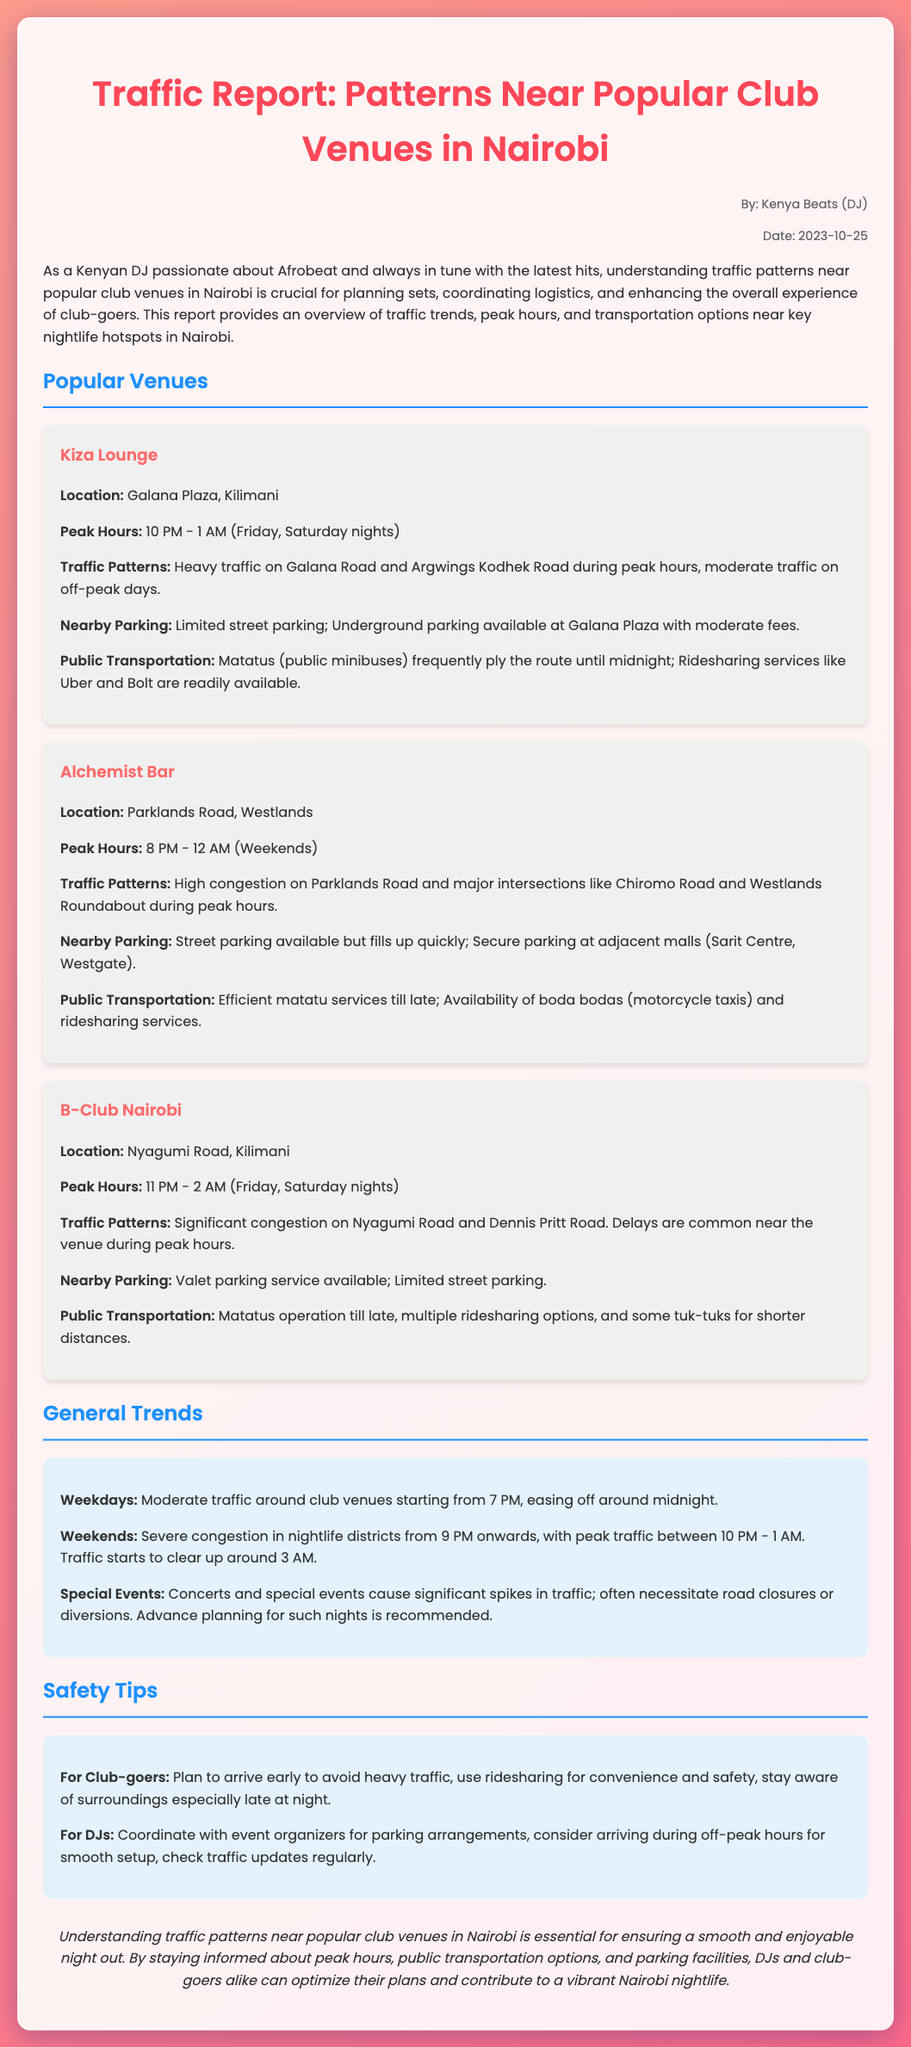What are the peak hours for Kiza Lounge? The peak hours for Kiza Lounge are specifically mentioned as 10 PM - 1 AM on Friday and Saturday nights.
Answer: 10 PM - 1 AM (Friday, Saturday nights) Where is Alchemist Bar located? The document specifies the location of Alchemist Bar as Parklands Road, Westlands.
Answer: Parklands Road, Westlands What type of traffic is experienced at B-Club Nairobi during peak hours? The document describes the traffic at B-Club Nairobi as significant congestion on Nyagumi Road and Dennis Pritt Road during peak hours.
Answer: Significant congestion What are the public transportation options for Kiza Lounge? The report mentions that matatus frequently ply the route until midnight and that ridesharing services like Uber and Bolt are readily available.
Answer: Matatus, Uber, Bolt What is suggested for DJs regarding parking arrangements? The report advises DJs to coordinate with event organizers for parking arrangements to ease logistics.
Answer: Coordinate with event organizers What impact do special events have on traffic? According to the report, special events cause significant spikes in traffic and often necessitate road closures or diversions.
Answer: Significant spikes What is the recommended action for club-goers to avoid heavy traffic? The document suggests that club-goers should plan to arrive early to avoid heavy traffic, enhancing their club experience.
Answer: Arrive early When does traffic typically start to clear up during weekends? The document indicates that traffic starts to clear up around 3 AM during weekends.
Answer: 3 AM 